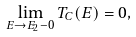Convert formula to latex. <formula><loc_0><loc_0><loc_500><loc_500>\lim _ { E \to E _ { 2 } - 0 } T _ { C } ( E ) = 0 ,</formula> 